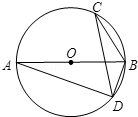What properties of circles can help in solving problems like this? To solve problems involving circles effectively, several key properties and theorems can be utilized: 1. The inscribed angle theorem, which tells us that an angle inscribed in a circle is half the measure of the subtended arc. 2. Thales' theorem, as seen here, where the angle in a semicircle is 90 degrees due to the diameter. 3. The property of angles at a point, where all angles around a point sum to 360 degrees. 4. The fact that angles subtended by the same arc are equal. These concepts frequently allow us to find unknown angles and lengths when dealing with circle diagrams. 